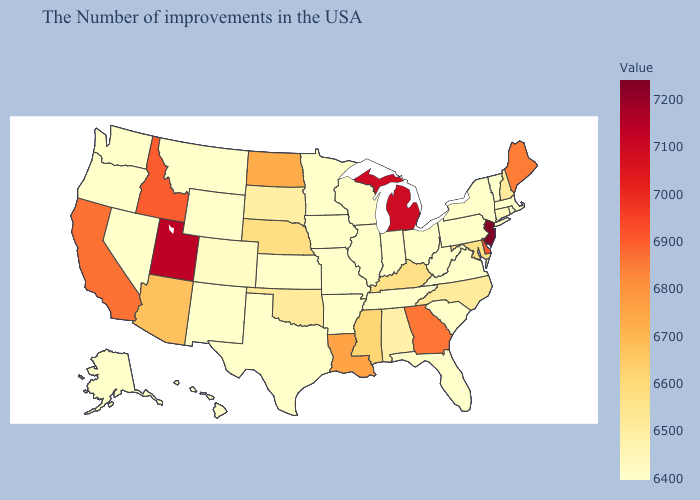Among the states that border Colorado , does Wyoming have the lowest value?
Concise answer only. Yes. Among the states that border Indiana , which have the lowest value?
Quick response, please. Ohio, Illinois. Which states have the highest value in the USA?
Write a very short answer. New Jersey. Does Nebraska have a lower value than Utah?
Quick response, please. Yes. Among the states that border Wyoming , which have the lowest value?
Give a very brief answer. Montana. Among the states that border Ohio , which have the highest value?
Quick response, please. Michigan. Does Mississippi have a higher value than North Dakota?
Give a very brief answer. No. Which states have the lowest value in the USA?
Give a very brief answer. Massachusetts, Rhode Island, Vermont, New York, Pennsylvania, Virginia, South Carolina, West Virginia, Ohio, Florida, Indiana, Tennessee, Wisconsin, Illinois, Missouri, Arkansas, Minnesota, Iowa, Kansas, Texas, Wyoming, New Mexico, Montana, Nevada, Washington, Oregon, Alaska, Hawaii. Does Oklahoma have the lowest value in the South?
Short answer required. No. 